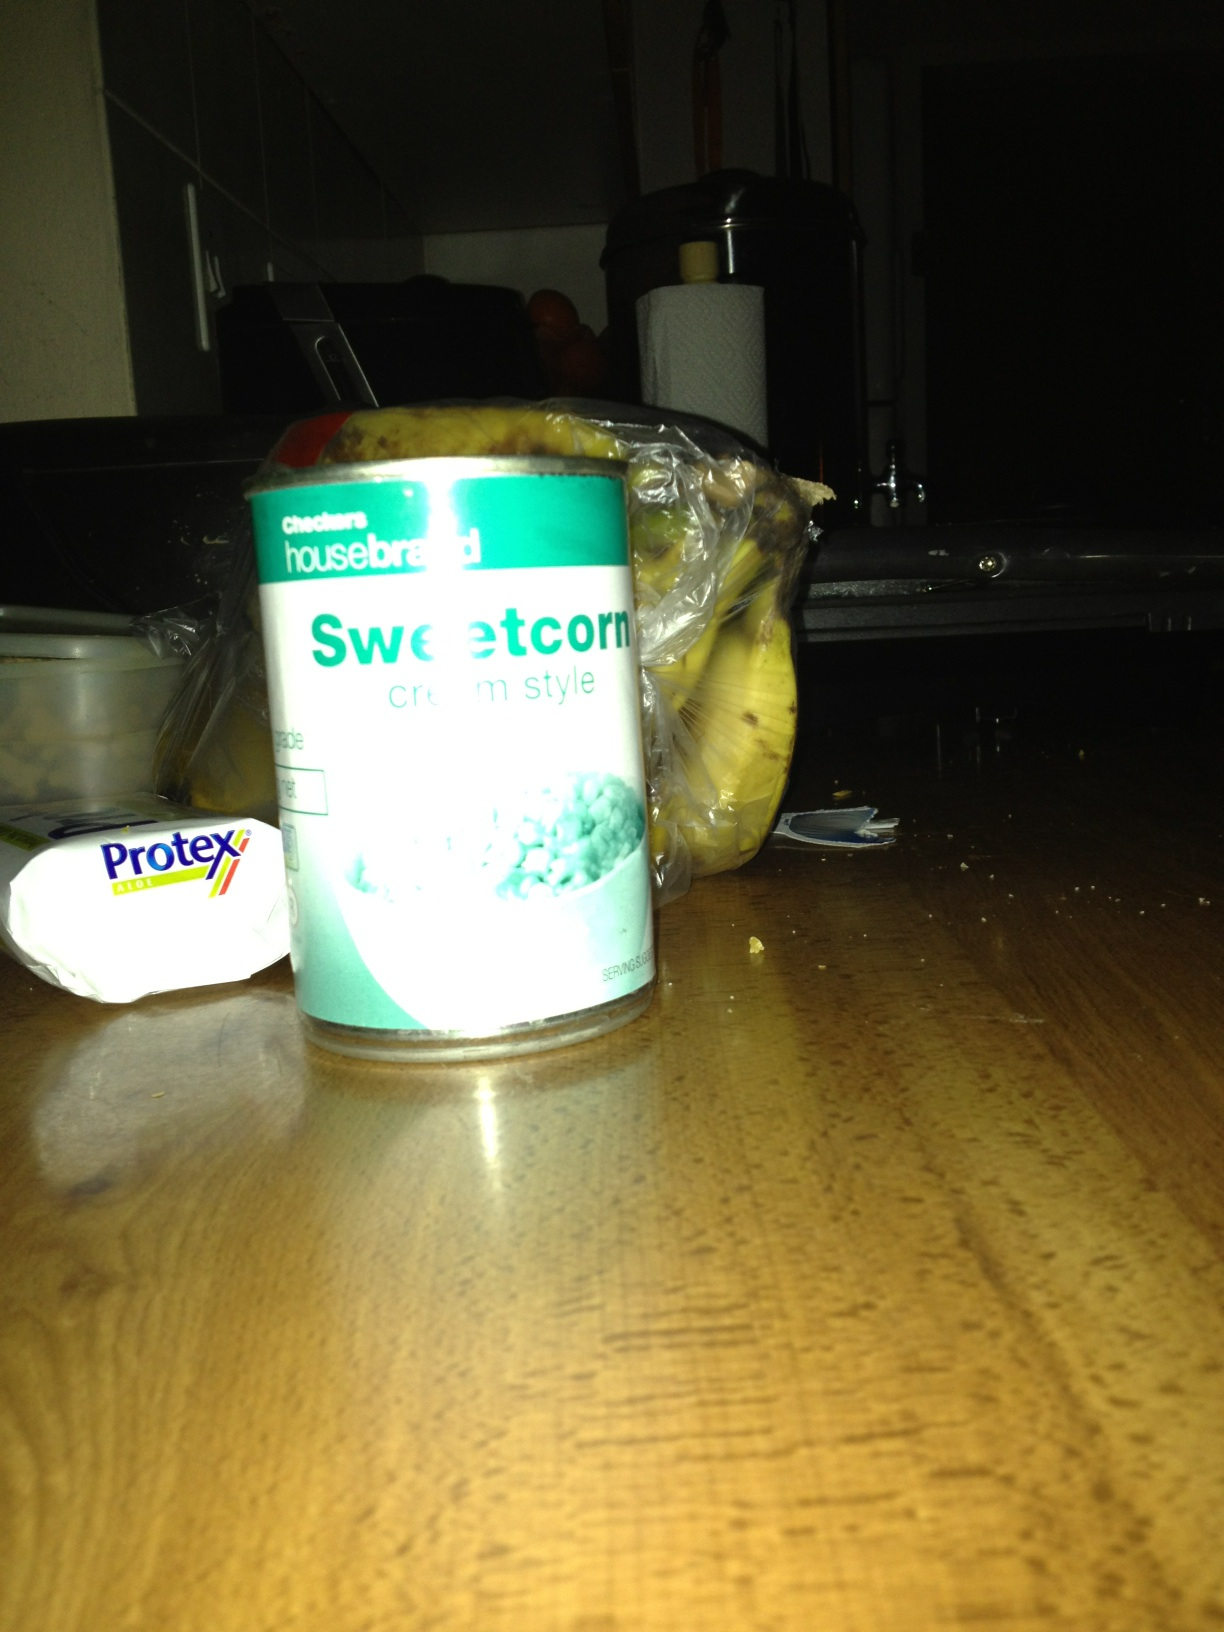What could be paired with the sweetcorn in a meal? Sweetcorn can be paired wonderfully with a variety of dishes. It goes great with grilled chicken, as part of a salad with tomatoes and avocados, or mixed into mashed potatoes for added texture and sweetness. You can also create corn chowder, combining this creamy sweetcorn with potatoes, bacon, and onions. Any creative dish ideas involving sweetcorn? How about trying a sweetcorn and black bean salsa? You can combine the sweetcorn with black beans, red bell pepper, jalapeño, cilantro, lime juice, and a bit of salt and pepper. It's a refreshing and colorful side dish perfect for summer cookouts or as a topping for tacos and grilled fish. 